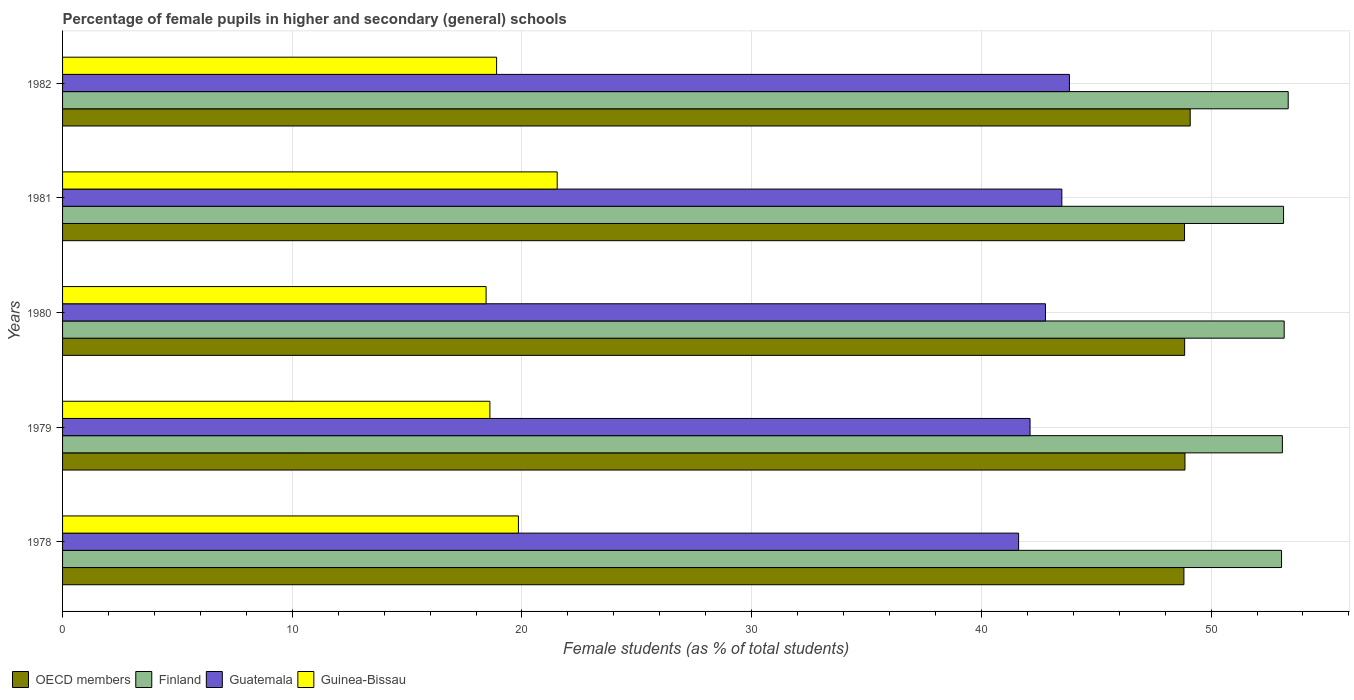Are the number of bars per tick equal to the number of legend labels?
Give a very brief answer. Yes. Are the number of bars on each tick of the Y-axis equal?
Your answer should be compact. Yes. How many bars are there on the 3rd tick from the top?
Provide a short and direct response. 4. How many bars are there on the 2nd tick from the bottom?
Ensure brevity in your answer.  4. What is the label of the 1st group of bars from the top?
Offer a very short reply. 1982. In how many cases, is the number of bars for a given year not equal to the number of legend labels?
Your answer should be compact. 0. What is the percentage of female pupils in higher and secondary schools in Guinea-Bissau in 1982?
Ensure brevity in your answer.  18.9. Across all years, what is the maximum percentage of female pupils in higher and secondary schools in Finland?
Keep it short and to the point. 53.36. Across all years, what is the minimum percentage of female pupils in higher and secondary schools in Finland?
Keep it short and to the point. 53.07. In which year was the percentage of female pupils in higher and secondary schools in OECD members maximum?
Provide a succinct answer. 1982. In which year was the percentage of female pupils in higher and secondary schools in Finland minimum?
Your response must be concise. 1978. What is the total percentage of female pupils in higher and secondary schools in Guinea-Bissau in the graph?
Give a very brief answer. 97.32. What is the difference between the percentage of female pupils in higher and secondary schools in Finland in 1981 and that in 1982?
Provide a short and direct response. -0.2. What is the difference between the percentage of female pupils in higher and secondary schools in OECD members in 1978 and the percentage of female pupils in higher and secondary schools in Guatemala in 1982?
Give a very brief answer. 4.98. What is the average percentage of female pupils in higher and secondary schools in Guinea-Bissau per year?
Give a very brief answer. 19.46. In the year 1979, what is the difference between the percentage of female pupils in higher and secondary schools in Guinea-Bissau and percentage of female pupils in higher and secondary schools in Guatemala?
Provide a succinct answer. -23.52. In how many years, is the percentage of female pupils in higher and secondary schools in Finland greater than 46 %?
Your answer should be very brief. 5. What is the ratio of the percentage of female pupils in higher and secondary schools in OECD members in 1978 to that in 1980?
Ensure brevity in your answer.  1. Is the percentage of female pupils in higher and secondary schools in Guinea-Bissau in 1980 less than that in 1981?
Provide a short and direct response. Yes. What is the difference between the highest and the second highest percentage of female pupils in higher and secondary schools in Guatemala?
Your answer should be compact. 0.33. What is the difference between the highest and the lowest percentage of female pupils in higher and secondary schools in Finland?
Make the answer very short. 0.29. In how many years, is the percentage of female pupils in higher and secondary schools in Finland greater than the average percentage of female pupils in higher and secondary schools in Finland taken over all years?
Offer a very short reply. 2. Is the sum of the percentage of female pupils in higher and secondary schools in OECD members in 1981 and 1982 greater than the maximum percentage of female pupils in higher and secondary schools in Finland across all years?
Make the answer very short. Yes. What does the 4th bar from the top in 1981 represents?
Provide a short and direct response. OECD members. What does the 2nd bar from the bottom in 1979 represents?
Your answer should be compact. Finland. Is it the case that in every year, the sum of the percentage of female pupils in higher and secondary schools in Finland and percentage of female pupils in higher and secondary schools in OECD members is greater than the percentage of female pupils in higher and secondary schools in Guatemala?
Provide a short and direct response. Yes. How many bars are there?
Ensure brevity in your answer.  20. Are all the bars in the graph horizontal?
Provide a succinct answer. Yes. How many years are there in the graph?
Provide a succinct answer. 5. What is the difference between two consecutive major ticks on the X-axis?
Offer a very short reply. 10. Does the graph contain grids?
Your answer should be compact. Yes. Where does the legend appear in the graph?
Your answer should be compact. Bottom left. How many legend labels are there?
Keep it short and to the point. 4. What is the title of the graph?
Ensure brevity in your answer.  Percentage of female pupils in higher and secondary (general) schools. Does "Jordan" appear as one of the legend labels in the graph?
Provide a succinct answer. No. What is the label or title of the X-axis?
Your response must be concise. Female students (as % of total students). What is the Female students (as % of total students) of OECD members in 1978?
Ensure brevity in your answer.  48.82. What is the Female students (as % of total students) in Finland in 1978?
Provide a short and direct response. 53.07. What is the Female students (as % of total students) of Guatemala in 1978?
Make the answer very short. 41.62. What is the Female students (as % of total students) of Guinea-Bissau in 1978?
Keep it short and to the point. 19.85. What is the Female students (as % of total students) in OECD members in 1979?
Offer a very short reply. 48.86. What is the Female students (as % of total students) of Finland in 1979?
Keep it short and to the point. 53.1. What is the Female students (as % of total students) in Guatemala in 1979?
Ensure brevity in your answer.  42.12. What is the Female students (as % of total students) of Guinea-Bissau in 1979?
Give a very brief answer. 18.6. What is the Female students (as % of total students) of OECD members in 1980?
Ensure brevity in your answer.  48.85. What is the Female students (as % of total students) in Finland in 1980?
Offer a terse response. 53.18. What is the Female students (as % of total students) in Guatemala in 1980?
Your response must be concise. 42.79. What is the Female students (as % of total students) of Guinea-Bissau in 1980?
Offer a very short reply. 18.44. What is the Female students (as % of total students) of OECD members in 1981?
Keep it short and to the point. 48.84. What is the Female students (as % of total students) of Finland in 1981?
Give a very brief answer. 53.16. What is the Female students (as % of total students) of Guatemala in 1981?
Make the answer very short. 43.5. What is the Female students (as % of total students) of Guinea-Bissau in 1981?
Ensure brevity in your answer.  21.53. What is the Female students (as % of total students) of OECD members in 1982?
Offer a terse response. 49.09. What is the Female students (as % of total students) of Finland in 1982?
Your answer should be compact. 53.36. What is the Female students (as % of total students) of Guatemala in 1982?
Your answer should be very brief. 43.83. What is the Female students (as % of total students) in Guinea-Bissau in 1982?
Keep it short and to the point. 18.9. Across all years, what is the maximum Female students (as % of total students) of OECD members?
Make the answer very short. 49.09. Across all years, what is the maximum Female students (as % of total students) in Finland?
Make the answer very short. 53.36. Across all years, what is the maximum Female students (as % of total students) of Guatemala?
Your answer should be compact. 43.83. Across all years, what is the maximum Female students (as % of total students) in Guinea-Bissau?
Your answer should be very brief. 21.53. Across all years, what is the minimum Female students (as % of total students) of OECD members?
Your response must be concise. 48.82. Across all years, what is the minimum Female students (as % of total students) of Finland?
Offer a terse response. 53.07. Across all years, what is the minimum Female students (as % of total students) in Guatemala?
Your response must be concise. 41.62. Across all years, what is the minimum Female students (as % of total students) in Guinea-Bissau?
Keep it short and to the point. 18.44. What is the total Female students (as % of total students) of OECD members in the graph?
Ensure brevity in your answer.  244.47. What is the total Female students (as % of total students) of Finland in the graph?
Make the answer very short. 265.87. What is the total Female students (as % of total students) of Guatemala in the graph?
Ensure brevity in your answer.  213.87. What is the total Female students (as % of total students) of Guinea-Bissau in the graph?
Your response must be concise. 97.32. What is the difference between the Female students (as % of total students) of OECD members in 1978 and that in 1979?
Give a very brief answer. -0.05. What is the difference between the Female students (as % of total students) in Finland in 1978 and that in 1979?
Keep it short and to the point. -0.04. What is the difference between the Female students (as % of total students) in Guatemala in 1978 and that in 1979?
Offer a terse response. -0.5. What is the difference between the Female students (as % of total students) in Guinea-Bissau in 1978 and that in 1979?
Offer a very short reply. 1.24. What is the difference between the Female students (as % of total students) of OECD members in 1978 and that in 1980?
Provide a succinct answer. -0.03. What is the difference between the Female students (as % of total students) in Finland in 1978 and that in 1980?
Provide a succinct answer. -0.11. What is the difference between the Female students (as % of total students) in Guatemala in 1978 and that in 1980?
Keep it short and to the point. -1.17. What is the difference between the Female students (as % of total students) in Guinea-Bissau in 1978 and that in 1980?
Give a very brief answer. 1.41. What is the difference between the Female students (as % of total students) of OECD members in 1978 and that in 1981?
Provide a succinct answer. -0.03. What is the difference between the Female students (as % of total students) of Finland in 1978 and that in 1981?
Your answer should be very brief. -0.09. What is the difference between the Female students (as % of total students) of Guatemala in 1978 and that in 1981?
Give a very brief answer. -1.88. What is the difference between the Female students (as % of total students) in Guinea-Bissau in 1978 and that in 1981?
Your answer should be very brief. -1.69. What is the difference between the Female students (as % of total students) of OECD members in 1978 and that in 1982?
Your response must be concise. -0.27. What is the difference between the Female students (as % of total students) of Finland in 1978 and that in 1982?
Make the answer very short. -0.29. What is the difference between the Female students (as % of total students) of Guatemala in 1978 and that in 1982?
Offer a very short reply. -2.21. What is the difference between the Female students (as % of total students) in Guinea-Bissau in 1978 and that in 1982?
Offer a terse response. 0.95. What is the difference between the Female students (as % of total students) of OECD members in 1979 and that in 1980?
Your answer should be compact. 0.01. What is the difference between the Female students (as % of total students) of Finland in 1979 and that in 1980?
Provide a succinct answer. -0.08. What is the difference between the Female students (as % of total students) in Guatemala in 1979 and that in 1980?
Keep it short and to the point. -0.67. What is the difference between the Female students (as % of total students) of Guinea-Bissau in 1979 and that in 1980?
Offer a terse response. 0.17. What is the difference between the Female students (as % of total students) in OECD members in 1979 and that in 1981?
Offer a terse response. 0.02. What is the difference between the Female students (as % of total students) of Finland in 1979 and that in 1981?
Your response must be concise. -0.05. What is the difference between the Female students (as % of total students) in Guatemala in 1979 and that in 1981?
Ensure brevity in your answer.  -1.38. What is the difference between the Female students (as % of total students) of Guinea-Bissau in 1979 and that in 1981?
Provide a short and direct response. -2.93. What is the difference between the Female students (as % of total students) in OECD members in 1979 and that in 1982?
Ensure brevity in your answer.  -0.23. What is the difference between the Female students (as % of total students) of Finland in 1979 and that in 1982?
Provide a short and direct response. -0.25. What is the difference between the Female students (as % of total students) in Guatemala in 1979 and that in 1982?
Make the answer very short. -1.71. What is the difference between the Female students (as % of total students) in Guinea-Bissau in 1979 and that in 1982?
Offer a very short reply. -0.29. What is the difference between the Female students (as % of total students) of OECD members in 1980 and that in 1981?
Your answer should be very brief. 0.01. What is the difference between the Female students (as % of total students) of Finland in 1980 and that in 1981?
Keep it short and to the point. 0.03. What is the difference between the Female students (as % of total students) of Guatemala in 1980 and that in 1981?
Provide a short and direct response. -0.71. What is the difference between the Female students (as % of total students) of Guinea-Bissau in 1980 and that in 1981?
Your answer should be compact. -3.1. What is the difference between the Female students (as % of total students) in OECD members in 1980 and that in 1982?
Your response must be concise. -0.24. What is the difference between the Female students (as % of total students) of Finland in 1980 and that in 1982?
Provide a succinct answer. -0.18. What is the difference between the Female students (as % of total students) in Guatemala in 1980 and that in 1982?
Keep it short and to the point. -1.04. What is the difference between the Female students (as % of total students) in Guinea-Bissau in 1980 and that in 1982?
Give a very brief answer. -0.46. What is the difference between the Female students (as % of total students) of OECD members in 1981 and that in 1982?
Keep it short and to the point. -0.25. What is the difference between the Female students (as % of total students) in Finland in 1981 and that in 1982?
Offer a terse response. -0.2. What is the difference between the Female students (as % of total students) of Guatemala in 1981 and that in 1982?
Make the answer very short. -0.33. What is the difference between the Female students (as % of total students) in Guinea-Bissau in 1981 and that in 1982?
Offer a terse response. 2.64. What is the difference between the Female students (as % of total students) in OECD members in 1978 and the Female students (as % of total students) in Finland in 1979?
Provide a succinct answer. -4.29. What is the difference between the Female students (as % of total students) of OECD members in 1978 and the Female students (as % of total students) of Guatemala in 1979?
Keep it short and to the point. 6.7. What is the difference between the Female students (as % of total students) of OECD members in 1978 and the Female students (as % of total students) of Guinea-Bissau in 1979?
Provide a succinct answer. 30.21. What is the difference between the Female students (as % of total students) in Finland in 1978 and the Female students (as % of total students) in Guatemala in 1979?
Make the answer very short. 10.95. What is the difference between the Female students (as % of total students) in Finland in 1978 and the Female students (as % of total students) in Guinea-Bissau in 1979?
Keep it short and to the point. 34.47. What is the difference between the Female students (as % of total students) of Guatemala in 1978 and the Female students (as % of total students) of Guinea-Bissau in 1979?
Your answer should be very brief. 23.02. What is the difference between the Female students (as % of total students) in OECD members in 1978 and the Female students (as % of total students) in Finland in 1980?
Provide a short and direct response. -4.37. What is the difference between the Female students (as % of total students) in OECD members in 1978 and the Female students (as % of total students) in Guatemala in 1980?
Give a very brief answer. 6.03. What is the difference between the Female students (as % of total students) in OECD members in 1978 and the Female students (as % of total students) in Guinea-Bissau in 1980?
Provide a short and direct response. 30.38. What is the difference between the Female students (as % of total students) of Finland in 1978 and the Female students (as % of total students) of Guatemala in 1980?
Ensure brevity in your answer.  10.28. What is the difference between the Female students (as % of total students) of Finland in 1978 and the Female students (as % of total students) of Guinea-Bissau in 1980?
Your answer should be very brief. 34.63. What is the difference between the Female students (as % of total students) of Guatemala in 1978 and the Female students (as % of total students) of Guinea-Bissau in 1980?
Offer a terse response. 23.18. What is the difference between the Female students (as % of total students) of OECD members in 1978 and the Female students (as % of total students) of Finland in 1981?
Keep it short and to the point. -4.34. What is the difference between the Female students (as % of total students) in OECD members in 1978 and the Female students (as % of total students) in Guatemala in 1981?
Your answer should be compact. 5.31. What is the difference between the Female students (as % of total students) in OECD members in 1978 and the Female students (as % of total students) in Guinea-Bissau in 1981?
Make the answer very short. 27.28. What is the difference between the Female students (as % of total students) in Finland in 1978 and the Female students (as % of total students) in Guatemala in 1981?
Your answer should be compact. 9.56. What is the difference between the Female students (as % of total students) in Finland in 1978 and the Female students (as % of total students) in Guinea-Bissau in 1981?
Your answer should be compact. 31.54. What is the difference between the Female students (as % of total students) of Guatemala in 1978 and the Female students (as % of total students) of Guinea-Bissau in 1981?
Provide a succinct answer. 20.09. What is the difference between the Female students (as % of total students) of OECD members in 1978 and the Female students (as % of total students) of Finland in 1982?
Make the answer very short. -4.54. What is the difference between the Female students (as % of total students) in OECD members in 1978 and the Female students (as % of total students) in Guatemala in 1982?
Offer a terse response. 4.98. What is the difference between the Female students (as % of total students) in OECD members in 1978 and the Female students (as % of total students) in Guinea-Bissau in 1982?
Give a very brief answer. 29.92. What is the difference between the Female students (as % of total students) of Finland in 1978 and the Female students (as % of total students) of Guatemala in 1982?
Keep it short and to the point. 9.24. What is the difference between the Female students (as % of total students) in Finland in 1978 and the Female students (as % of total students) in Guinea-Bissau in 1982?
Your answer should be compact. 34.17. What is the difference between the Female students (as % of total students) of Guatemala in 1978 and the Female students (as % of total students) of Guinea-Bissau in 1982?
Ensure brevity in your answer.  22.73. What is the difference between the Female students (as % of total students) in OECD members in 1979 and the Female students (as % of total students) in Finland in 1980?
Your answer should be very brief. -4.32. What is the difference between the Female students (as % of total students) in OECD members in 1979 and the Female students (as % of total students) in Guatemala in 1980?
Your answer should be very brief. 6.07. What is the difference between the Female students (as % of total students) in OECD members in 1979 and the Female students (as % of total students) in Guinea-Bissau in 1980?
Your response must be concise. 30.43. What is the difference between the Female students (as % of total students) of Finland in 1979 and the Female students (as % of total students) of Guatemala in 1980?
Offer a terse response. 10.31. What is the difference between the Female students (as % of total students) in Finland in 1979 and the Female students (as % of total students) in Guinea-Bissau in 1980?
Ensure brevity in your answer.  34.67. What is the difference between the Female students (as % of total students) in Guatemala in 1979 and the Female students (as % of total students) in Guinea-Bissau in 1980?
Your answer should be very brief. 23.68. What is the difference between the Female students (as % of total students) in OECD members in 1979 and the Female students (as % of total students) in Finland in 1981?
Keep it short and to the point. -4.29. What is the difference between the Female students (as % of total students) in OECD members in 1979 and the Female students (as % of total students) in Guatemala in 1981?
Your response must be concise. 5.36. What is the difference between the Female students (as % of total students) of OECD members in 1979 and the Female students (as % of total students) of Guinea-Bissau in 1981?
Keep it short and to the point. 27.33. What is the difference between the Female students (as % of total students) of Finland in 1979 and the Female students (as % of total students) of Guatemala in 1981?
Offer a very short reply. 9.6. What is the difference between the Female students (as % of total students) of Finland in 1979 and the Female students (as % of total students) of Guinea-Bissau in 1981?
Offer a very short reply. 31.57. What is the difference between the Female students (as % of total students) of Guatemala in 1979 and the Female students (as % of total students) of Guinea-Bissau in 1981?
Your answer should be compact. 20.59. What is the difference between the Female students (as % of total students) in OECD members in 1979 and the Female students (as % of total students) in Finland in 1982?
Your response must be concise. -4.49. What is the difference between the Female students (as % of total students) in OECD members in 1979 and the Female students (as % of total students) in Guatemala in 1982?
Ensure brevity in your answer.  5.03. What is the difference between the Female students (as % of total students) of OECD members in 1979 and the Female students (as % of total students) of Guinea-Bissau in 1982?
Your answer should be compact. 29.97. What is the difference between the Female students (as % of total students) in Finland in 1979 and the Female students (as % of total students) in Guatemala in 1982?
Provide a short and direct response. 9.27. What is the difference between the Female students (as % of total students) in Finland in 1979 and the Female students (as % of total students) in Guinea-Bissau in 1982?
Make the answer very short. 34.21. What is the difference between the Female students (as % of total students) of Guatemala in 1979 and the Female students (as % of total students) of Guinea-Bissau in 1982?
Offer a very short reply. 23.22. What is the difference between the Female students (as % of total students) of OECD members in 1980 and the Female students (as % of total students) of Finland in 1981?
Your answer should be very brief. -4.31. What is the difference between the Female students (as % of total students) of OECD members in 1980 and the Female students (as % of total students) of Guatemala in 1981?
Offer a very short reply. 5.35. What is the difference between the Female students (as % of total students) in OECD members in 1980 and the Female students (as % of total students) in Guinea-Bissau in 1981?
Provide a succinct answer. 27.32. What is the difference between the Female students (as % of total students) in Finland in 1980 and the Female students (as % of total students) in Guatemala in 1981?
Keep it short and to the point. 9.68. What is the difference between the Female students (as % of total students) in Finland in 1980 and the Female students (as % of total students) in Guinea-Bissau in 1981?
Your answer should be compact. 31.65. What is the difference between the Female students (as % of total students) of Guatemala in 1980 and the Female students (as % of total students) of Guinea-Bissau in 1981?
Keep it short and to the point. 21.26. What is the difference between the Female students (as % of total students) of OECD members in 1980 and the Female students (as % of total students) of Finland in 1982?
Give a very brief answer. -4.51. What is the difference between the Female students (as % of total students) of OECD members in 1980 and the Female students (as % of total students) of Guatemala in 1982?
Your answer should be compact. 5.02. What is the difference between the Female students (as % of total students) of OECD members in 1980 and the Female students (as % of total students) of Guinea-Bissau in 1982?
Give a very brief answer. 29.96. What is the difference between the Female students (as % of total students) in Finland in 1980 and the Female students (as % of total students) in Guatemala in 1982?
Ensure brevity in your answer.  9.35. What is the difference between the Female students (as % of total students) in Finland in 1980 and the Female students (as % of total students) in Guinea-Bissau in 1982?
Provide a short and direct response. 34.29. What is the difference between the Female students (as % of total students) of Guatemala in 1980 and the Female students (as % of total students) of Guinea-Bissau in 1982?
Your answer should be compact. 23.9. What is the difference between the Female students (as % of total students) of OECD members in 1981 and the Female students (as % of total students) of Finland in 1982?
Provide a succinct answer. -4.51. What is the difference between the Female students (as % of total students) in OECD members in 1981 and the Female students (as % of total students) in Guatemala in 1982?
Keep it short and to the point. 5.01. What is the difference between the Female students (as % of total students) of OECD members in 1981 and the Female students (as % of total students) of Guinea-Bissau in 1982?
Your response must be concise. 29.95. What is the difference between the Female students (as % of total students) in Finland in 1981 and the Female students (as % of total students) in Guatemala in 1982?
Offer a very short reply. 9.32. What is the difference between the Female students (as % of total students) in Finland in 1981 and the Female students (as % of total students) in Guinea-Bissau in 1982?
Offer a very short reply. 34.26. What is the difference between the Female students (as % of total students) of Guatemala in 1981 and the Female students (as % of total students) of Guinea-Bissau in 1982?
Your answer should be very brief. 24.61. What is the average Female students (as % of total students) of OECD members per year?
Provide a succinct answer. 48.89. What is the average Female students (as % of total students) of Finland per year?
Provide a short and direct response. 53.17. What is the average Female students (as % of total students) of Guatemala per year?
Provide a succinct answer. 42.77. What is the average Female students (as % of total students) in Guinea-Bissau per year?
Your response must be concise. 19.46. In the year 1978, what is the difference between the Female students (as % of total students) of OECD members and Female students (as % of total students) of Finland?
Give a very brief answer. -4.25. In the year 1978, what is the difference between the Female students (as % of total students) in OECD members and Female students (as % of total students) in Guatemala?
Your answer should be very brief. 7.2. In the year 1978, what is the difference between the Female students (as % of total students) of OECD members and Female students (as % of total students) of Guinea-Bissau?
Your answer should be very brief. 28.97. In the year 1978, what is the difference between the Female students (as % of total students) of Finland and Female students (as % of total students) of Guatemala?
Your response must be concise. 11.45. In the year 1978, what is the difference between the Female students (as % of total students) of Finland and Female students (as % of total students) of Guinea-Bissau?
Provide a short and direct response. 33.22. In the year 1978, what is the difference between the Female students (as % of total students) of Guatemala and Female students (as % of total students) of Guinea-Bissau?
Give a very brief answer. 21.78. In the year 1979, what is the difference between the Female students (as % of total students) of OECD members and Female students (as % of total students) of Finland?
Give a very brief answer. -4.24. In the year 1979, what is the difference between the Female students (as % of total students) of OECD members and Female students (as % of total students) of Guatemala?
Provide a short and direct response. 6.74. In the year 1979, what is the difference between the Female students (as % of total students) in OECD members and Female students (as % of total students) in Guinea-Bissau?
Provide a succinct answer. 30.26. In the year 1979, what is the difference between the Female students (as % of total students) of Finland and Female students (as % of total students) of Guatemala?
Provide a short and direct response. 10.98. In the year 1979, what is the difference between the Female students (as % of total students) in Finland and Female students (as % of total students) in Guinea-Bissau?
Provide a short and direct response. 34.5. In the year 1979, what is the difference between the Female students (as % of total students) in Guatemala and Female students (as % of total students) in Guinea-Bissau?
Provide a short and direct response. 23.52. In the year 1980, what is the difference between the Female students (as % of total students) of OECD members and Female students (as % of total students) of Finland?
Give a very brief answer. -4.33. In the year 1980, what is the difference between the Female students (as % of total students) of OECD members and Female students (as % of total students) of Guatemala?
Make the answer very short. 6.06. In the year 1980, what is the difference between the Female students (as % of total students) of OECD members and Female students (as % of total students) of Guinea-Bissau?
Offer a very short reply. 30.41. In the year 1980, what is the difference between the Female students (as % of total students) in Finland and Female students (as % of total students) in Guatemala?
Give a very brief answer. 10.39. In the year 1980, what is the difference between the Female students (as % of total students) in Finland and Female students (as % of total students) in Guinea-Bissau?
Provide a succinct answer. 34.74. In the year 1980, what is the difference between the Female students (as % of total students) of Guatemala and Female students (as % of total students) of Guinea-Bissau?
Provide a succinct answer. 24.35. In the year 1981, what is the difference between the Female students (as % of total students) of OECD members and Female students (as % of total students) of Finland?
Keep it short and to the point. -4.31. In the year 1981, what is the difference between the Female students (as % of total students) in OECD members and Female students (as % of total students) in Guatemala?
Give a very brief answer. 5.34. In the year 1981, what is the difference between the Female students (as % of total students) of OECD members and Female students (as % of total students) of Guinea-Bissau?
Provide a succinct answer. 27.31. In the year 1981, what is the difference between the Female students (as % of total students) of Finland and Female students (as % of total students) of Guatemala?
Your response must be concise. 9.65. In the year 1981, what is the difference between the Female students (as % of total students) in Finland and Female students (as % of total students) in Guinea-Bissau?
Provide a short and direct response. 31.62. In the year 1981, what is the difference between the Female students (as % of total students) in Guatemala and Female students (as % of total students) in Guinea-Bissau?
Give a very brief answer. 21.97. In the year 1982, what is the difference between the Female students (as % of total students) of OECD members and Female students (as % of total students) of Finland?
Your answer should be compact. -4.27. In the year 1982, what is the difference between the Female students (as % of total students) in OECD members and Female students (as % of total students) in Guatemala?
Keep it short and to the point. 5.26. In the year 1982, what is the difference between the Female students (as % of total students) in OECD members and Female students (as % of total students) in Guinea-Bissau?
Keep it short and to the point. 30.2. In the year 1982, what is the difference between the Female students (as % of total students) of Finland and Female students (as % of total students) of Guatemala?
Provide a short and direct response. 9.53. In the year 1982, what is the difference between the Female students (as % of total students) of Finland and Female students (as % of total students) of Guinea-Bissau?
Make the answer very short. 34.46. In the year 1982, what is the difference between the Female students (as % of total students) of Guatemala and Female students (as % of total students) of Guinea-Bissau?
Provide a succinct answer. 24.94. What is the ratio of the Female students (as % of total students) in OECD members in 1978 to that in 1979?
Provide a succinct answer. 1. What is the ratio of the Female students (as % of total students) of Finland in 1978 to that in 1979?
Your response must be concise. 1. What is the ratio of the Female students (as % of total students) in Guatemala in 1978 to that in 1979?
Your response must be concise. 0.99. What is the ratio of the Female students (as % of total students) of Guinea-Bissau in 1978 to that in 1979?
Offer a terse response. 1.07. What is the ratio of the Female students (as % of total students) of OECD members in 1978 to that in 1980?
Keep it short and to the point. 1. What is the ratio of the Female students (as % of total students) in Guatemala in 1978 to that in 1980?
Provide a succinct answer. 0.97. What is the ratio of the Female students (as % of total students) in Guinea-Bissau in 1978 to that in 1980?
Your answer should be very brief. 1.08. What is the ratio of the Female students (as % of total students) in Finland in 1978 to that in 1981?
Give a very brief answer. 1. What is the ratio of the Female students (as % of total students) of Guatemala in 1978 to that in 1981?
Keep it short and to the point. 0.96. What is the ratio of the Female students (as % of total students) in Guinea-Bissau in 1978 to that in 1981?
Offer a very short reply. 0.92. What is the ratio of the Female students (as % of total students) in Finland in 1978 to that in 1982?
Provide a succinct answer. 0.99. What is the ratio of the Female students (as % of total students) in Guatemala in 1978 to that in 1982?
Make the answer very short. 0.95. What is the ratio of the Female students (as % of total students) in Guinea-Bissau in 1978 to that in 1982?
Your answer should be very brief. 1.05. What is the ratio of the Female students (as % of total students) of OECD members in 1979 to that in 1980?
Keep it short and to the point. 1. What is the ratio of the Female students (as % of total students) of Guatemala in 1979 to that in 1980?
Your answer should be compact. 0.98. What is the ratio of the Female students (as % of total students) in Guinea-Bissau in 1979 to that in 1980?
Offer a terse response. 1.01. What is the ratio of the Female students (as % of total students) in Finland in 1979 to that in 1981?
Offer a terse response. 1. What is the ratio of the Female students (as % of total students) in Guatemala in 1979 to that in 1981?
Your answer should be very brief. 0.97. What is the ratio of the Female students (as % of total students) of Guinea-Bissau in 1979 to that in 1981?
Provide a short and direct response. 0.86. What is the ratio of the Female students (as % of total students) in Finland in 1979 to that in 1982?
Give a very brief answer. 1. What is the ratio of the Female students (as % of total students) of Guatemala in 1979 to that in 1982?
Provide a succinct answer. 0.96. What is the ratio of the Female students (as % of total students) in Guinea-Bissau in 1979 to that in 1982?
Offer a very short reply. 0.98. What is the ratio of the Female students (as % of total students) of Finland in 1980 to that in 1981?
Offer a terse response. 1. What is the ratio of the Female students (as % of total students) in Guatemala in 1980 to that in 1981?
Your answer should be very brief. 0.98. What is the ratio of the Female students (as % of total students) of Guinea-Bissau in 1980 to that in 1981?
Ensure brevity in your answer.  0.86. What is the ratio of the Female students (as % of total students) of Finland in 1980 to that in 1982?
Ensure brevity in your answer.  1. What is the ratio of the Female students (as % of total students) in Guatemala in 1980 to that in 1982?
Provide a short and direct response. 0.98. What is the ratio of the Female students (as % of total students) in Guinea-Bissau in 1980 to that in 1982?
Offer a terse response. 0.98. What is the ratio of the Female students (as % of total students) of Finland in 1981 to that in 1982?
Offer a very short reply. 1. What is the ratio of the Female students (as % of total students) of Guatemala in 1981 to that in 1982?
Your response must be concise. 0.99. What is the ratio of the Female students (as % of total students) in Guinea-Bissau in 1981 to that in 1982?
Your answer should be compact. 1.14. What is the difference between the highest and the second highest Female students (as % of total students) of OECD members?
Your answer should be compact. 0.23. What is the difference between the highest and the second highest Female students (as % of total students) in Finland?
Provide a short and direct response. 0.18. What is the difference between the highest and the second highest Female students (as % of total students) of Guatemala?
Make the answer very short. 0.33. What is the difference between the highest and the second highest Female students (as % of total students) in Guinea-Bissau?
Give a very brief answer. 1.69. What is the difference between the highest and the lowest Female students (as % of total students) of OECD members?
Keep it short and to the point. 0.27. What is the difference between the highest and the lowest Female students (as % of total students) of Finland?
Keep it short and to the point. 0.29. What is the difference between the highest and the lowest Female students (as % of total students) in Guatemala?
Give a very brief answer. 2.21. What is the difference between the highest and the lowest Female students (as % of total students) of Guinea-Bissau?
Your answer should be very brief. 3.1. 